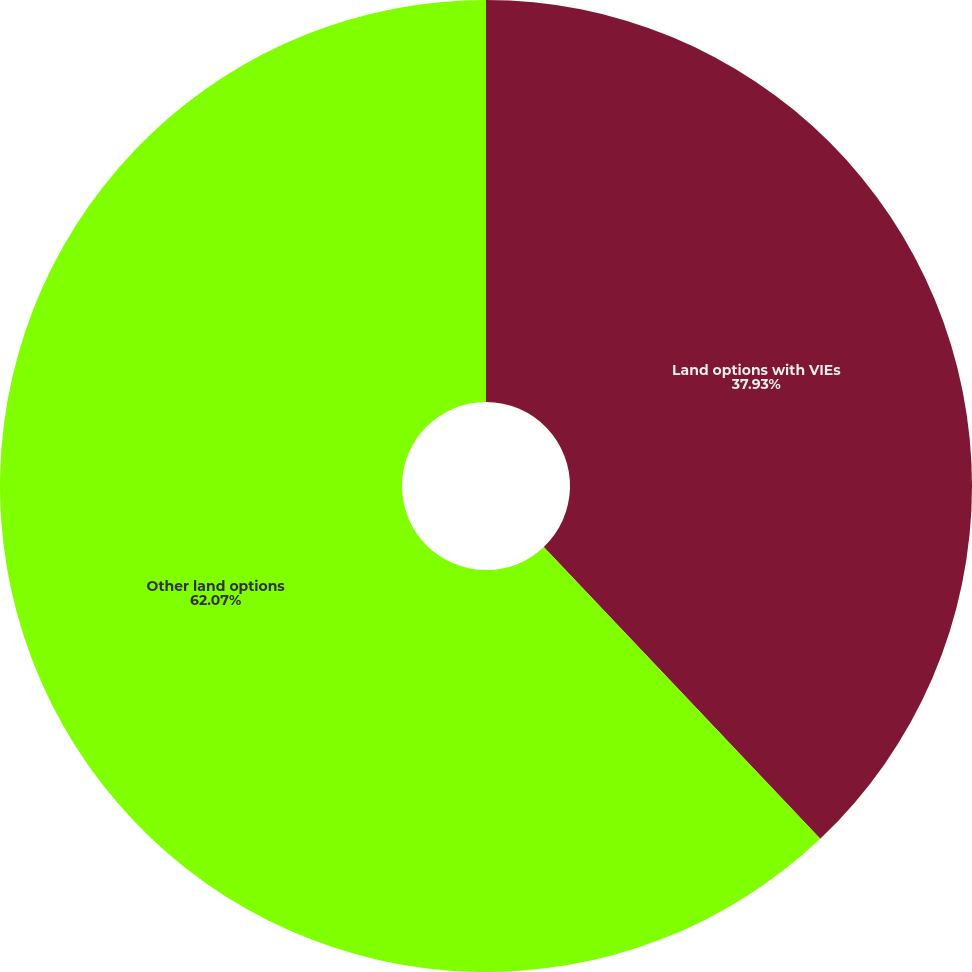<chart> <loc_0><loc_0><loc_500><loc_500><pie_chart><fcel>Land options with VIEs<fcel>Other land options<nl><fcel>37.93%<fcel>62.07%<nl></chart> 